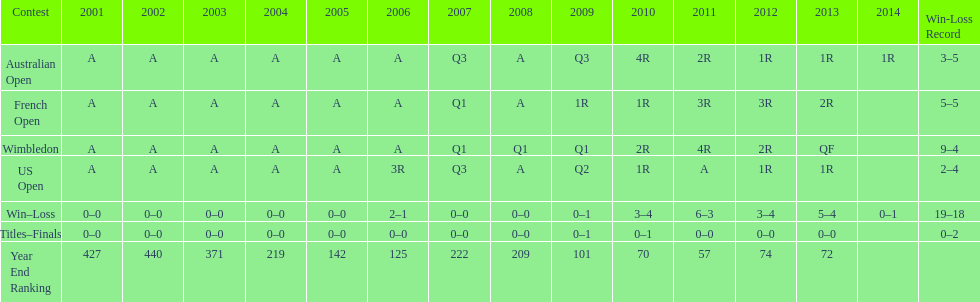How many total matches took place between 2001 and 2014? 37. 